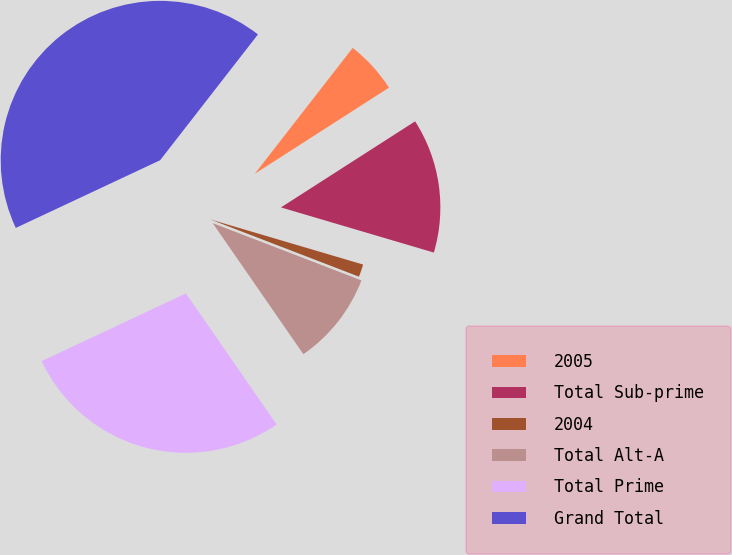<chart> <loc_0><loc_0><loc_500><loc_500><pie_chart><fcel>2005<fcel>Total Sub-prime<fcel>2004<fcel>Total Alt-A<fcel>Total Prime<fcel>Grand Total<nl><fcel>5.4%<fcel>13.65%<fcel>1.28%<fcel>9.52%<fcel>27.65%<fcel>42.5%<nl></chart> 